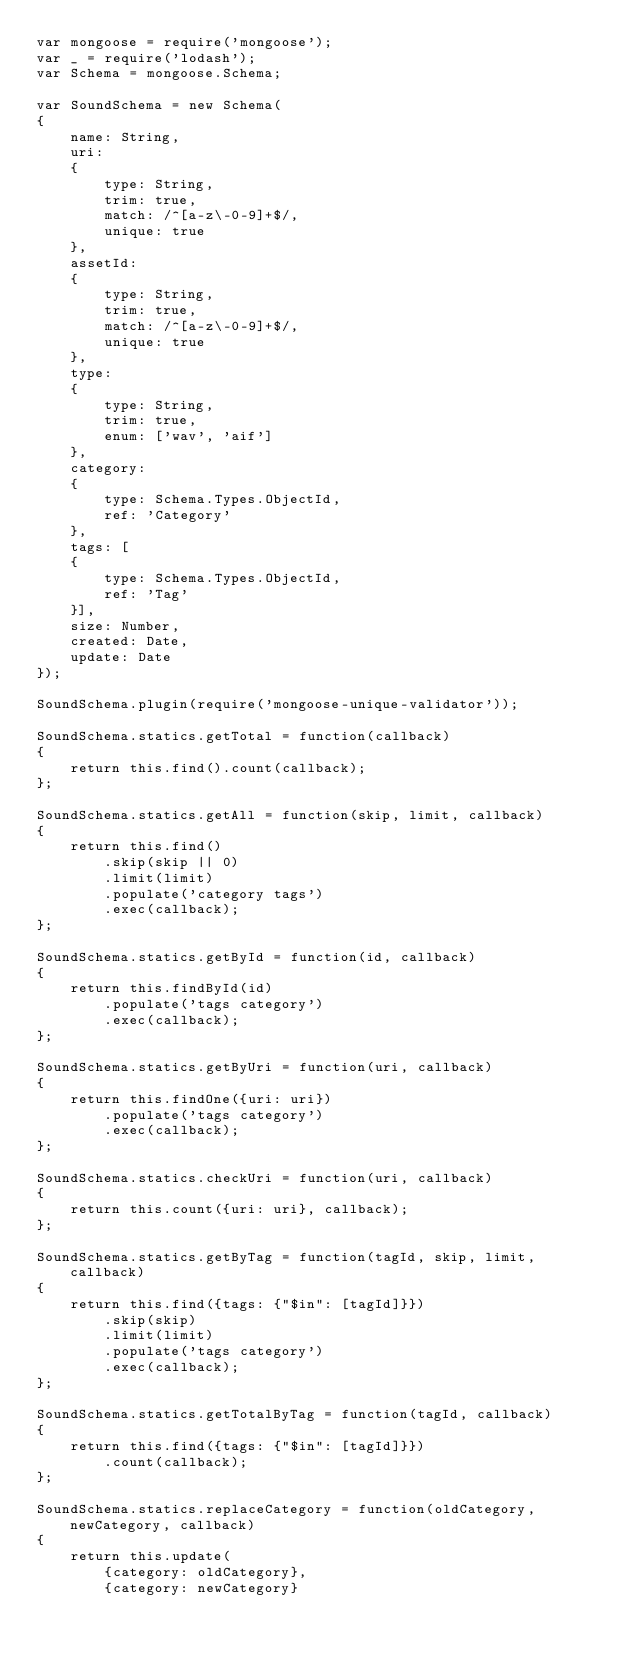Convert code to text. <code><loc_0><loc_0><loc_500><loc_500><_JavaScript_>var mongoose = require('mongoose');
var _ = require('lodash');
var Schema = mongoose.Schema;

var SoundSchema = new Schema(
{
	name: String,
	uri:
	{
		type: String,
		trim: true,
		match: /^[a-z\-0-9]+$/,
		unique: true
	},
	assetId:
	{
		type: String,
		trim: true,
		match: /^[a-z\-0-9]+$/,
		unique: true
	},
	type:
	{
		type: String,
		trim: true,
		enum: ['wav', 'aif']
	},
	category:
	{
		type: Schema.Types.ObjectId,
		ref: 'Category'
	},
	tags: [
	{
		type: Schema.Types.ObjectId,
		ref: 'Tag'
	}],
	size: Number,
	created: Date,
	update: Date
});

SoundSchema.plugin(require('mongoose-unique-validator'));

SoundSchema.statics.getTotal = function(callback)
{
	return this.find().count(callback);
};

SoundSchema.statics.getAll = function(skip, limit, callback)
{
	return this.find()
		.skip(skip || 0)
		.limit(limit)
		.populate('category tags')
		.exec(callback);
};

SoundSchema.statics.getById = function(id, callback)
{
	return this.findById(id)
		.populate('tags category')
		.exec(callback);
};

SoundSchema.statics.getByUri = function(uri, callback)
{
	return this.findOne({uri: uri})
		.populate('tags category')
		.exec(callback);
};

SoundSchema.statics.checkUri = function(uri, callback)
{
	return this.count({uri: uri}, callback);
};

SoundSchema.statics.getByTag = function(tagId, skip, limit, callback)
{
	return this.find({tags: {"$in": [tagId]}})
		.skip(skip)
		.limit(limit)
		.populate('tags category')
		.exec(callback);
};

SoundSchema.statics.getTotalByTag = function(tagId, callback)
{
	return this.find({tags: {"$in": [tagId]}})
		.count(callback);
};

SoundSchema.statics.replaceCategory = function(oldCategory, newCategory, callback)
{
	return this.update(
		{category: oldCategory}, 
		{category: newCategory}</code> 